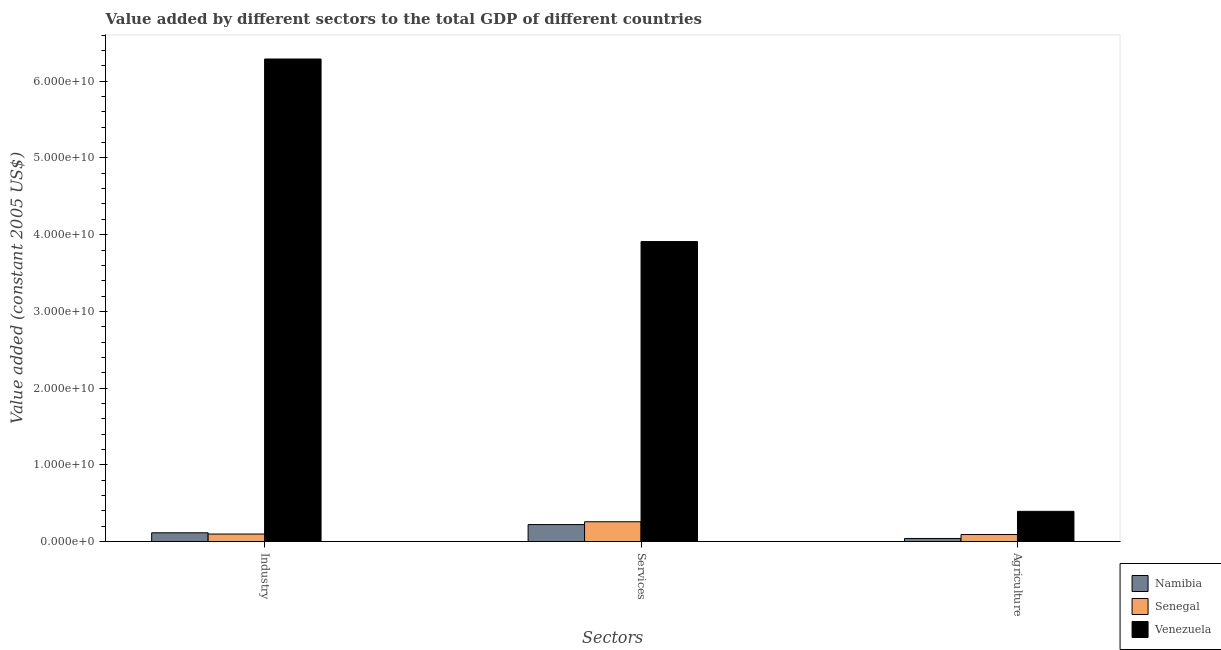Are the number of bars per tick equal to the number of legend labels?
Provide a succinct answer. Yes. Are the number of bars on each tick of the X-axis equal?
Your answer should be very brief. Yes. How many bars are there on the 2nd tick from the left?
Offer a terse response. 3. How many bars are there on the 2nd tick from the right?
Provide a succinct answer. 3. What is the label of the 2nd group of bars from the left?
Make the answer very short. Services. What is the value added by agricultural sector in Senegal?
Ensure brevity in your answer.  9.18e+08. Across all countries, what is the maximum value added by services?
Ensure brevity in your answer.  3.91e+1. Across all countries, what is the minimum value added by agricultural sector?
Provide a short and direct response. 4.04e+08. In which country was the value added by agricultural sector maximum?
Your answer should be very brief. Venezuela. In which country was the value added by agricultural sector minimum?
Provide a short and direct response. Namibia. What is the total value added by services in the graph?
Keep it short and to the point. 4.39e+1. What is the difference between the value added by agricultural sector in Namibia and that in Venezuela?
Offer a very short reply. -3.53e+09. What is the difference between the value added by agricultural sector in Senegal and the value added by services in Namibia?
Provide a short and direct response. -1.30e+09. What is the average value added by agricultural sector per country?
Give a very brief answer. 1.75e+09. What is the difference between the value added by agricultural sector and value added by services in Senegal?
Your answer should be compact. -1.66e+09. In how many countries, is the value added by industrial sector greater than 52000000000 US$?
Your answer should be very brief. 1. What is the ratio of the value added by industrial sector in Senegal to that in Namibia?
Your answer should be compact. 0.86. Is the value added by agricultural sector in Namibia less than that in Senegal?
Your response must be concise. Yes. Is the difference between the value added by agricultural sector in Namibia and Venezuela greater than the difference between the value added by services in Namibia and Venezuela?
Offer a very short reply. Yes. What is the difference between the highest and the second highest value added by services?
Offer a terse response. 3.65e+1. What is the difference between the highest and the lowest value added by agricultural sector?
Provide a short and direct response. 3.53e+09. In how many countries, is the value added by industrial sector greater than the average value added by industrial sector taken over all countries?
Keep it short and to the point. 1. What does the 1st bar from the left in Industry represents?
Keep it short and to the point. Namibia. What does the 2nd bar from the right in Services represents?
Make the answer very short. Senegal. How many bars are there?
Give a very brief answer. 9. How many countries are there in the graph?
Provide a succinct answer. 3. What is the difference between two consecutive major ticks on the Y-axis?
Your answer should be very brief. 1.00e+1. Are the values on the major ticks of Y-axis written in scientific E-notation?
Offer a very short reply. Yes. Does the graph contain grids?
Keep it short and to the point. No. How many legend labels are there?
Provide a succinct answer. 3. What is the title of the graph?
Your answer should be compact. Value added by different sectors to the total GDP of different countries. What is the label or title of the X-axis?
Your answer should be very brief. Sectors. What is the label or title of the Y-axis?
Provide a short and direct response. Value added (constant 2005 US$). What is the Value added (constant 2005 US$) in Namibia in Industry?
Your answer should be very brief. 1.14e+09. What is the Value added (constant 2005 US$) in Senegal in Industry?
Your answer should be compact. 9.80e+08. What is the Value added (constant 2005 US$) of Venezuela in Industry?
Your answer should be very brief. 6.29e+1. What is the Value added (constant 2005 US$) in Namibia in Services?
Your response must be concise. 2.21e+09. What is the Value added (constant 2005 US$) in Senegal in Services?
Offer a terse response. 2.58e+09. What is the Value added (constant 2005 US$) of Venezuela in Services?
Offer a very short reply. 3.91e+1. What is the Value added (constant 2005 US$) of Namibia in Agriculture?
Ensure brevity in your answer.  4.04e+08. What is the Value added (constant 2005 US$) of Senegal in Agriculture?
Your response must be concise. 9.18e+08. What is the Value added (constant 2005 US$) of Venezuela in Agriculture?
Keep it short and to the point. 3.94e+09. Across all Sectors, what is the maximum Value added (constant 2005 US$) in Namibia?
Offer a very short reply. 2.21e+09. Across all Sectors, what is the maximum Value added (constant 2005 US$) of Senegal?
Your answer should be compact. 2.58e+09. Across all Sectors, what is the maximum Value added (constant 2005 US$) of Venezuela?
Your response must be concise. 6.29e+1. Across all Sectors, what is the minimum Value added (constant 2005 US$) of Namibia?
Ensure brevity in your answer.  4.04e+08. Across all Sectors, what is the minimum Value added (constant 2005 US$) of Senegal?
Offer a very short reply. 9.18e+08. Across all Sectors, what is the minimum Value added (constant 2005 US$) of Venezuela?
Provide a short and direct response. 3.94e+09. What is the total Value added (constant 2005 US$) in Namibia in the graph?
Ensure brevity in your answer.  3.76e+09. What is the total Value added (constant 2005 US$) in Senegal in the graph?
Offer a very short reply. 4.48e+09. What is the total Value added (constant 2005 US$) of Venezuela in the graph?
Make the answer very short. 1.06e+11. What is the difference between the Value added (constant 2005 US$) in Namibia in Industry and that in Services?
Offer a very short reply. -1.07e+09. What is the difference between the Value added (constant 2005 US$) of Senegal in Industry and that in Services?
Offer a very short reply. -1.60e+09. What is the difference between the Value added (constant 2005 US$) in Venezuela in Industry and that in Services?
Your answer should be compact. 2.38e+1. What is the difference between the Value added (constant 2005 US$) in Namibia in Industry and that in Agriculture?
Make the answer very short. 7.39e+08. What is the difference between the Value added (constant 2005 US$) in Senegal in Industry and that in Agriculture?
Your answer should be very brief. 6.23e+07. What is the difference between the Value added (constant 2005 US$) in Venezuela in Industry and that in Agriculture?
Your answer should be very brief. 5.90e+1. What is the difference between the Value added (constant 2005 US$) in Namibia in Services and that in Agriculture?
Keep it short and to the point. 1.81e+09. What is the difference between the Value added (constant 2005 US$) of Senegal in Services and that in Agriculture?
Your response must be concise. 1.66e+09. What is the difference between the Value added (constant 2005 US$) of Venezuela in Services and that in Agriculture?
Offer a very short reply. 3.52e+1. What is the difference between the Value added (constant 2005 US$) in Namibia in Industry and the Value added (constant 2005 US$) in Senegal in Services?
Keep it short and to the point. -1.44e+09. What is the difference between the Value added (constant 2005 US$) of Namibia in Industry and the Value added (constant 2005 US$) of Venezuela in Services?
Provide a succinct answer. -3.80e+1. What is the difference between the Value added (constant 2005 US$) in Senegal in Industry and the Value added (constant 2005 US$) in Venezuela in Services?
Provide a short and direct response. -3.81e+1. What is the difference between the Value added (constant 2005 US$) in Namibia in Industry and the Value added (constant 2005 US$) in Senegal in Agriculture?
Make the answer very short. 2.25e+08. What is the difference between the Value added (constant 2005 US$) in Namibia in Industry and the Value added (constant 2005 US$) in Venezuela in Agriculture?
Offer a very short reply. -2.80e+09. What is the difference between the Value added (constant 2005 US$) in Senegal in Industry and the Value added (constant 2005 US$) in Venezuela in Agriculture?
Make the answer very short. -2.96e+09. What is the difference between the Value added (constant 2005 US$) of Namibia in Services and the Value added (constant 2005 US$) of Senegal in Agriculture?
Provide a short and direct response. 1.30e+09. What is the difference between the Value added (constant 2005 US$) in Namibia in Services and the Value added (constant 2005 US$) in Venezuela in Agriculture?
Give a very brief answer. -1.72e+09. What is the difference between the Value added (constant 2005 US$) in Senegal in Services and the Value added (constant 2005 US$) in Venezuela in Agriculture?
Give a very brief answer. -1.36e+09. What is the average Value added (constant 2005 US$) in Namibia per Sectors?
Ensure brevity in your answer.  1.25e+09. What is the average Value added (constant 2005 US$) in Senegal per Sectors?
Give a very brief answer. 1.49e+09. What is the average Value added (constant 2005 US$) of Venezuela per Sectors?
Provide a succinct answer. 3.53e+1. What is the difference between the Value added (constant 2005 US$) in Namibia and Value added (constant 2005 US$) in Senegal in Industry?
Provide a succinct answer. 1.63e+08. What is the difference between the Value added (constant 2005 US$) in Namibia and Value added (constant 2005 US$) in Venezuela in Industry?
Ensure brevity in your answer.  -6.18e+1. What is the difference between the Value added (constant 2005 US$) in Senegal and Value added (constant 2005 US$) in Venezuela in Industry?
Your response must be concise. -6.19e+1. What is the difference between the Value added (constant 2005 US$) in Namibia and Value added (constant 2005 US$) in Senegal in Services?
Your answer should be very brief. -3.68e+08. What is the difference between the Value added (constant 2005 US$) in Namibia and Value added (constant 2005 US$) in Venezuela in Services?
Your answer should be compact. -3.69e+1. What is the difference between the Value added (constant 2005 US$) in Senegal and Value added (constant 2005 US$) in Venezuela in Services?
Your answer should be compact. -3.65e+1. What is the difference between the Value added (constant 2005 US$) in Namibia and Value added (constant 2005 US$) in Senegal in Agriculture?
Keep it short and to the point. -5.14e+08. What is the difference between the Value added (constant 2005 US$) of Namibia and Value added (constant 2005 US$) of Venezuela in Agriculture?
Make the answer very short. -3.53e+09. What is the difference between the Value added (constant 2005 US$) of Senegal and Value added (constant 2005 US$) of Venezuela in Agriculture?
Give a very brief answer. -3.02e+09. What is the ratio of the Value added (constant 2005 US$) in Namibia in Industry to that in Services?
Provide a succinct answer. 0.52. What is the ratio of the Value added (constant 2005 US$) of Senegal in Industry to that in Services?
Provide a succinct answer. 0.38. What is the ratio of the Value added (constant 2005 US$) of Venezuela in Industry to that in Services?
Provide a succinct answer. 1.61. What is the ratio of the Value added (constant 2005 US$) in Namibia in Industry to that in Agriculture?
Keep it short and to the point. 2.83. What is the ratio of the Value added (constant 2005 US$) in Senegal in Industry to that in Agriculture?
Give a very brief answer. 1.07. What is the ratio of the Value added (constant 2005 US$) of Venezuela in Industry to that in Agriculture?
Your answer should be very brief. 15.97. What is the ratio of the Value added (constant 2005 US$) of Namibia in Services to that in Agriculture?
Provide a succinct answer. 5.48. What is the ratio of the Value added (constant 2005 US$) in Senegal in Services to that in Agriculture?
Keep it short and to the point. 2.81. What is the ratio of the Value added (constant 2005 US$) of Venezuela in Services to that in Agriculture?
Your answer should be very brief. 9.93. What is the difference between the highest and the second highest Value added (constant 2005 US$) in Namibia?
Give a very brief answer. 1.07e+09. What is the difference between the highest and the second highest Value added (constant 2005 US$) in Senegal?
Make the answer very short. 1.60e+09. What is the difference between the highest and the second highest Value added (constant 2005 US$) of Venezuela?
Give a very brief answer. 2.38e+1. What is the difference between the highest and the lowest Value added (constant 2005 US$) in Namibia?
Offer a terse response. 1.81e+09. What is the difference between the highest and the lowest Value added (constant 2005 US$) in Senegal?
Ensure brevity in your answer.  1.66e+09. What is the difference between the highest and the lowest Value added (constant 2005 US$) in Venezuela?
Your response must be concise. 5.90e+1. 